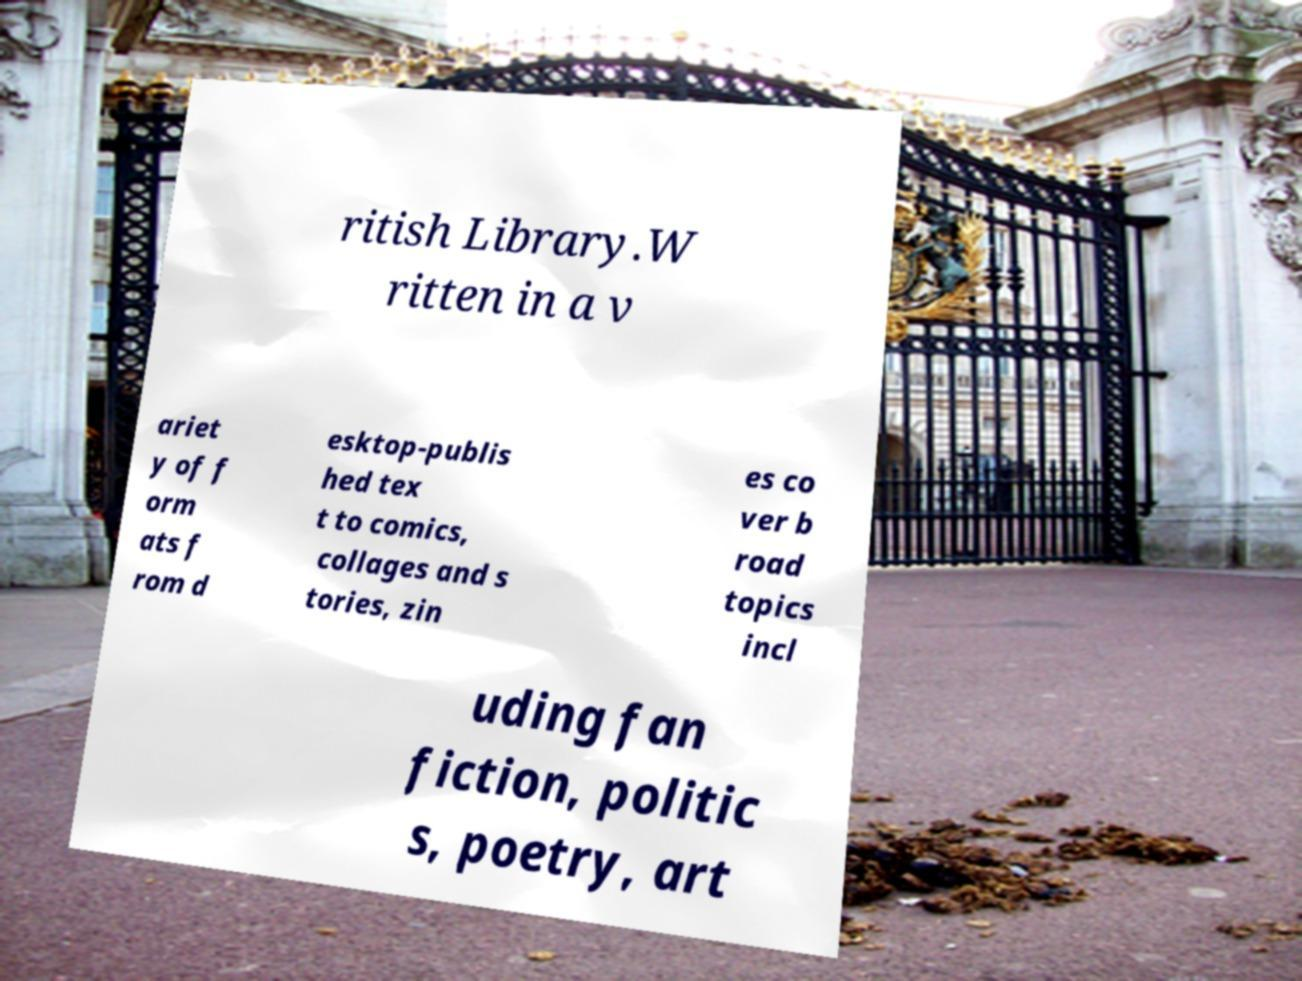Can you accurately transcribe the text from the provided image for me? ritish Library.W ritten in a v ariet y of f orm ats f rom d esktop-publis hed tex t to comics, collages and s tories, zin es co ver b road topics incl uding fan fiction, politic s, poetry, art 